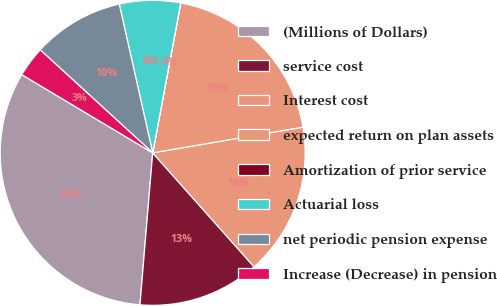Convert chart to OTSL. <chart><loc_0><loc_0><loc_500><loc_500><pie_chart><fcel>(Millions of Dollars)<fcel>service cost<fcel>Interest cost<fcel>expected return on plan assets<fcel>Amortization of prior service<fcel>Actuarial loss<fcel>net periodic pension expense<fcel>Increase (Decrease) in pension<nl><fcel>32.24%<fcel>12.9%<fcel>16.13%<fcel>19.35%<fcel>0.01%<fcel>6.46%<fcel>9.68%<fcel>3.23%<nl></chart> 